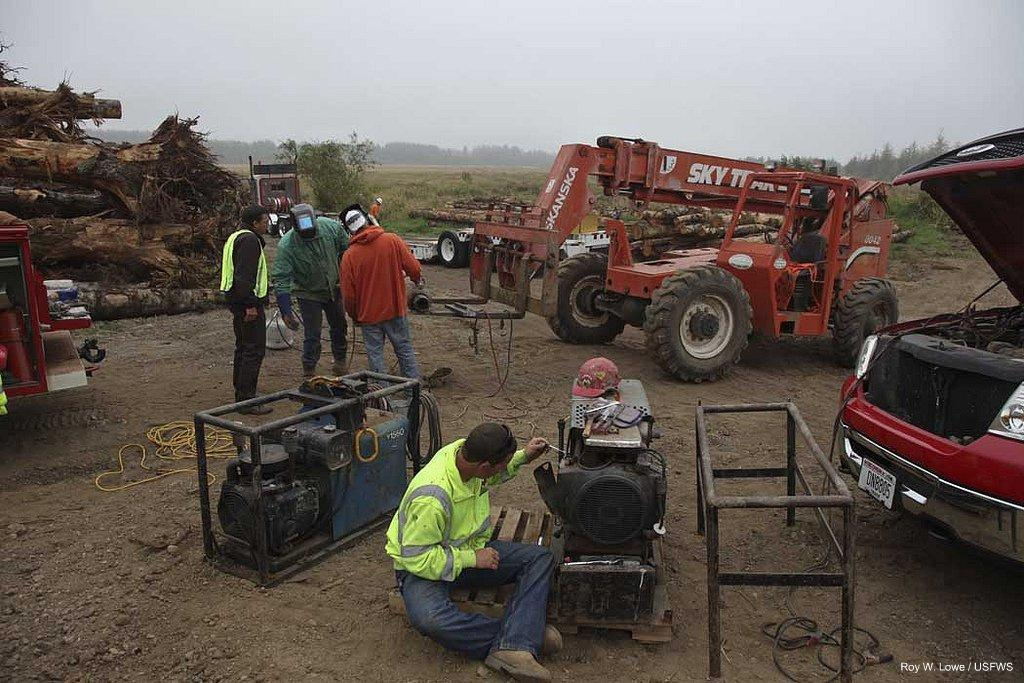What types of objects can be seen in the image? There are vehicles, wooden logs, machines, and stands visible in the image. How many people are present in the image? There are five people in the image. What is on the ground in the image? There are objects on the ground in the image. What can be seen in the background of the image? There is grass, trees, and the sky visible in the background of the image. What alley can be seen in the image? There is no alley present in the image. What sound can be heard coming from the machines in the image? The image does not provide any information about the sounds produced by the machines, so it cannot be determined from the image. 